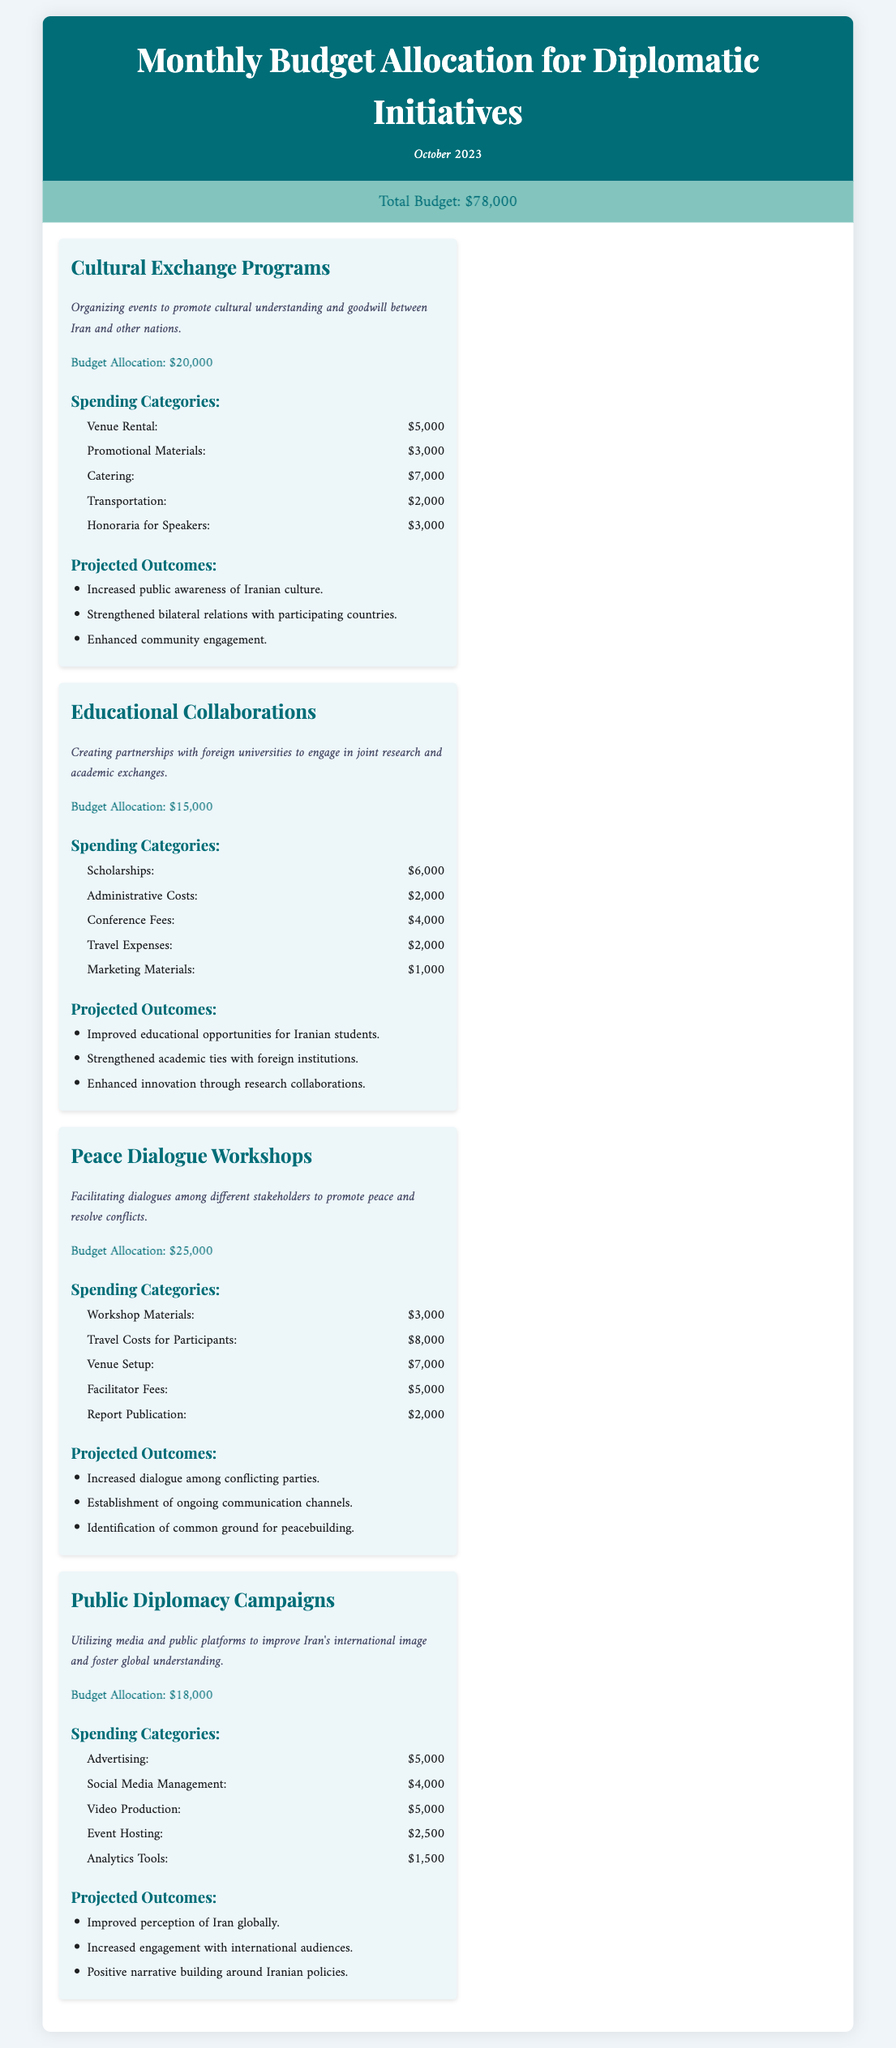What is the total budget for October 2023? The total budget is presented at the top of the document as part of the budget summary.
Answer: $78,000 What initiative has the largest budget allocation? The budget allocations for each initiative can be compared to determine which is the largest.
Answer: Peace Dialogue Workshops How much is allocated for Cultural Exchange Programs? Cultural Exchange Programs' budget allocation is stated directly in the initiative section.
Answer: $20,000 What is the total spending on Transportation across all initiatives? Transportation costs are specified for each initiative. The costs are summed up to get the total.
Answer: $10,000 What is a projected outcome of the Public Diplomacy Campaigns? Each initiative has listed projected outcomes, and one can retrieve a specific outcome from the corresponding section.
Answer: Improved perception of Iran globally What is the amount spent on Workshop Materials in Peace Dialogue Workshops? The spending categories for Peace Dialogue Workshops provide the cost for Workshop Materials.
Answer: $3,000 Which initiative focuses on educational collaborations? The title of the initiative indicates its focus, making it simple to identify.
Answer: Educational Collaborations What is the budget allocation for Public Diplomacy Campaigns? Budget allocations are clearly listed under each initiative's budget section.
Answer: $18,000 What is the spending for Facilitator Fees in Peace Dialogue Workshops? The spending categories for Peace Dialogue Workshops specify the cost for Facilitator Fees.
Answer: $5,000 How many spending categories are listed for Educational Collaborations? The spending categories section under each initiative lists the number of categories.
Answer: 5 